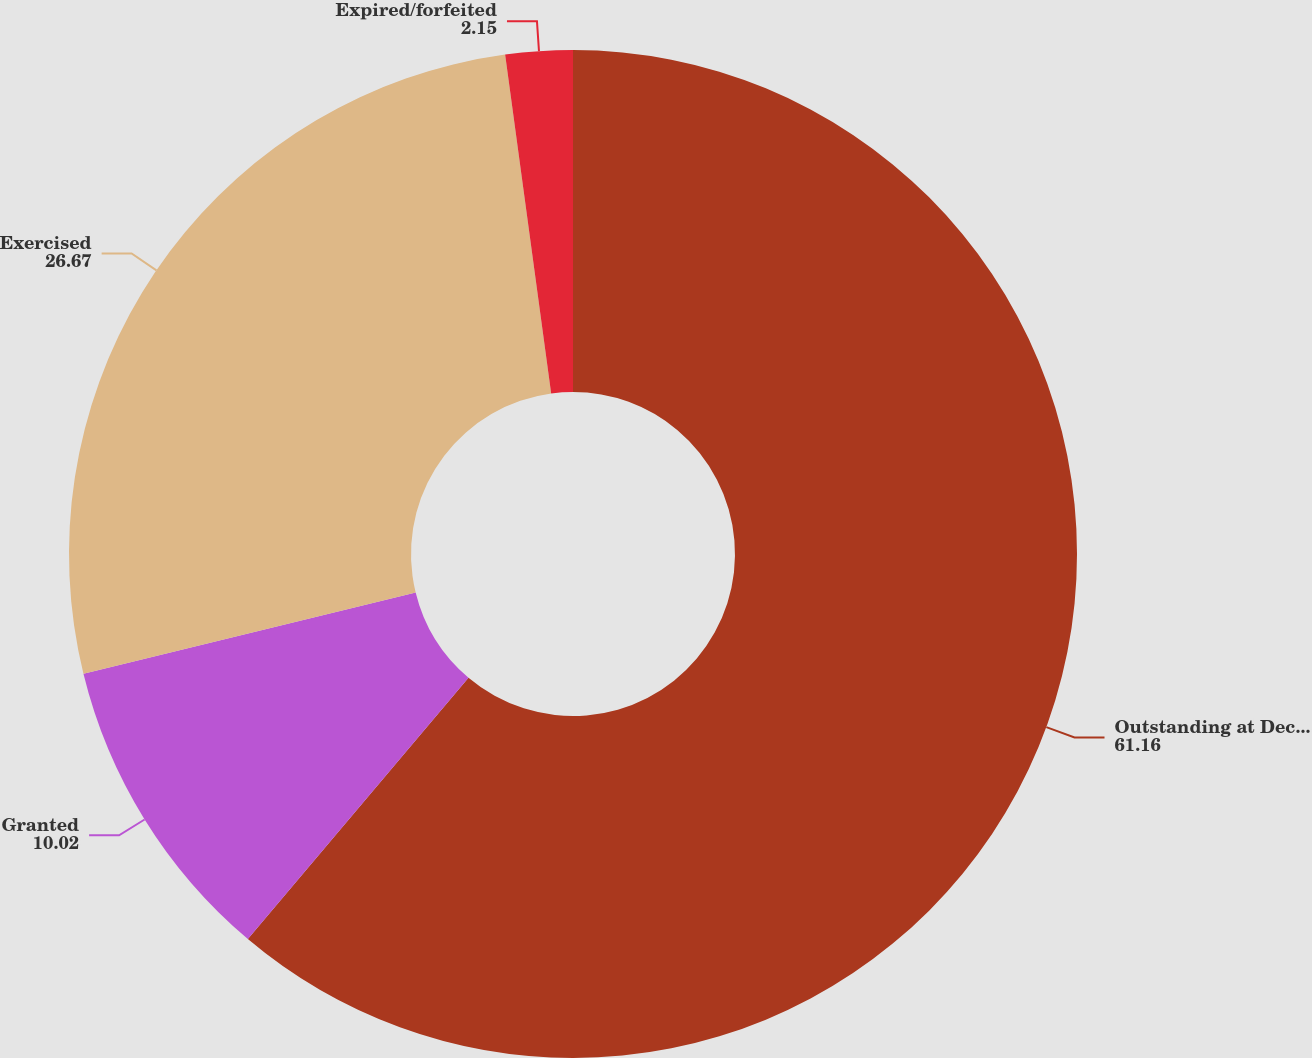<chart> <loc_0><loc_0><loc_500><loc_500><pie_chart><fcel>Outstanding at December 31<fcel>Granted<fcel>Exercised<fcel>Expired/forfeited<nl><fcel>61.16%<fcel>10.02%<fcel>26.67%<fcel>2.15%<nl></chart> 